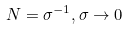Convert formula to latex. <formula><loc_0><loc_0><loc_500><loc_500>N = \sigma ^ { - 1 } , \sigma \rightarrow 0</formula> 